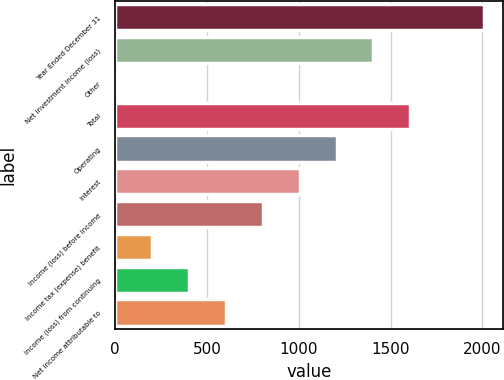Convert chart to OTSL. <chart><loc_0><loc_0><loc_500><loc_500><bar_chart><fcel>Year Ended December 31<fcel>Net investment income (loss)<fcel>Other<fcel>Total<fcel>Operating<fcel>Interest<fcel>Income (loss) before income<fcel>Income tax (expense) benefit<fcel>Income (loss) from continuing<fcel>Net income attributable to<nl><fcel>2009<fcel>1406.6<fcel>1<fcel>1607.4<fcel>1205.8<fcel>1005<fcel>804.2<fcel>201.8<fcel>402.6<fcel>603.4<nl></chart> 